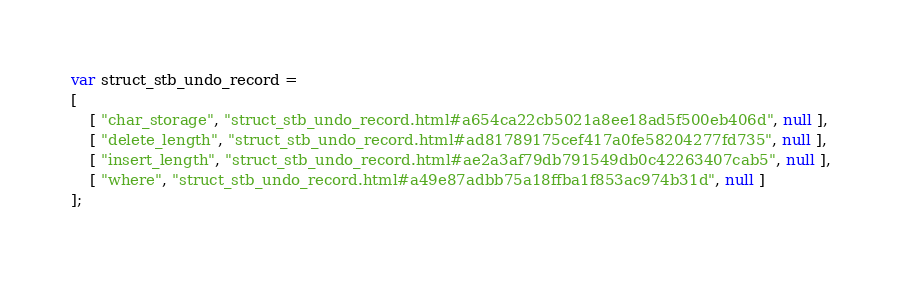Convert code to text. <code><loc_0><loc_0><loc_500><loc_500><_JavaScript_>var struct_stb_undo_record =
[
    [ "char_storage", "struct_stb_undo_record.html#a654ca22cb5021a8ee18ad5f500eb406d", null ],
    [ "delete_length", "struct_stb_undo_record.html#ad81789175cef417a0fe58204277fd735", null ],
    [ "insert_length", "struct_stb_undo_record.html#ae2a3af79db791549db0c42263407cab5", null ],
    [ "where", "struct_stb_undo_record.html#a49e87adbb75a18ffba1f853ac974b31d", null ]
];</code> 